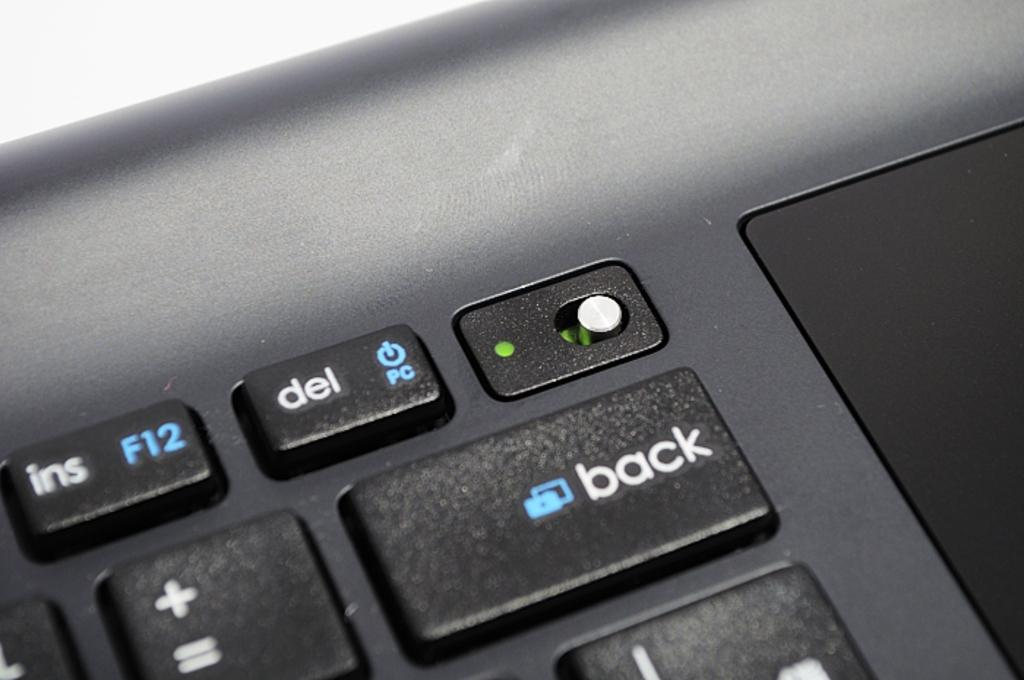What is: What is the main subject of the image? The main subject of the image is the keys of a laptop. Can you describe the keys in more detail? The keys are the individual buttons on the laptop that are used for typing and inputting commands. What type of engine can be seen powering the beast in the image? There is no engine or beast present in the image; it only features the keys of a laptop. 